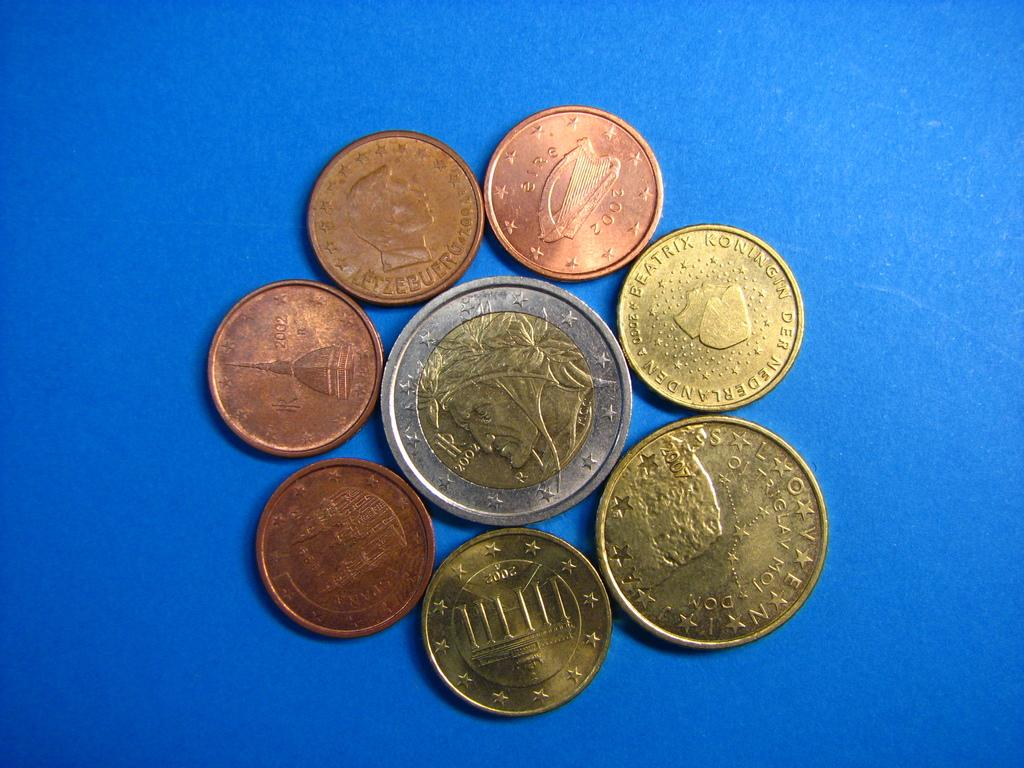<image>
Relay a brief, clear account of the picture shown. Several coins are displayed on a blue background, including a 2002 copper coin and one that says Beatrix Koningin Der Nederlanden on it. 